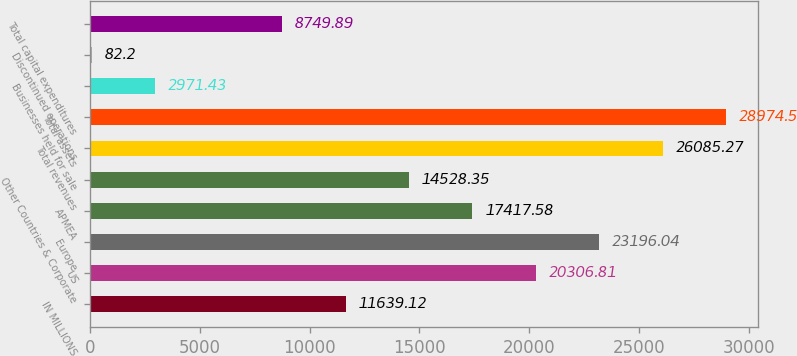<chart> <loc_0><loc_0><loc_500><loc_500><bar_chart><fcel>IN MILLIONS<fcel>US<fcel>Europe<fcel>APMEA<fcel>Other Countries & Corporate<fcel>Total revenues<fcel>Total assets<fcel>Businesses held for sale<fcel>Discontinued operations<fcel>Total capital expenditures<nl><fcel>11639.1<fcel>20306.8<fcel>23196<fcel>17417.6<fcel>14528.4<fcel>26085.3<fcel>28974.5<fcel>2971.43<fcel>82.2<fcel>8749.89<nl></chart> 